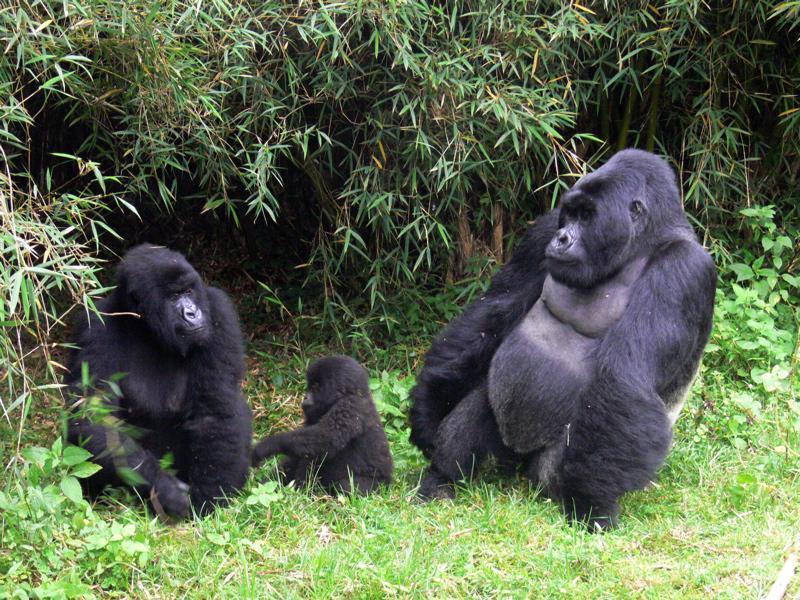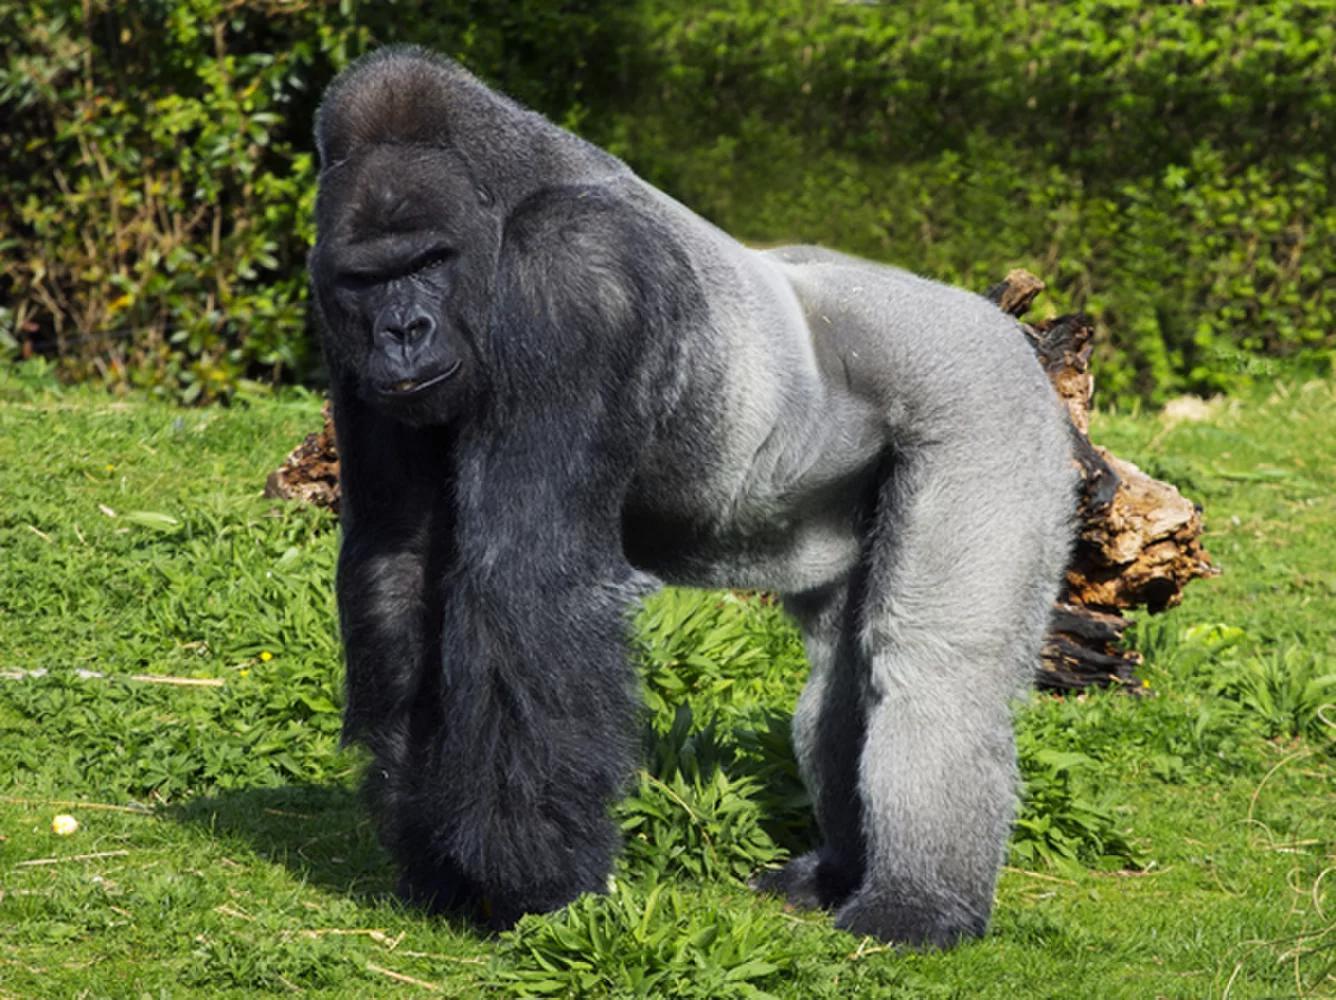The first image is the image on the left, the second image is the image on the right. Considering the images on both sides, is "In one of the images there is a baby gorilla near at least one adult gorilla." valid? Answer yes or no. Yes. 